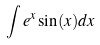Convert formula to latex. <formula><loc_0><loc_0><loc_500><loc_500>\int e ^ { x } \sin ( x ) d x</formula> 